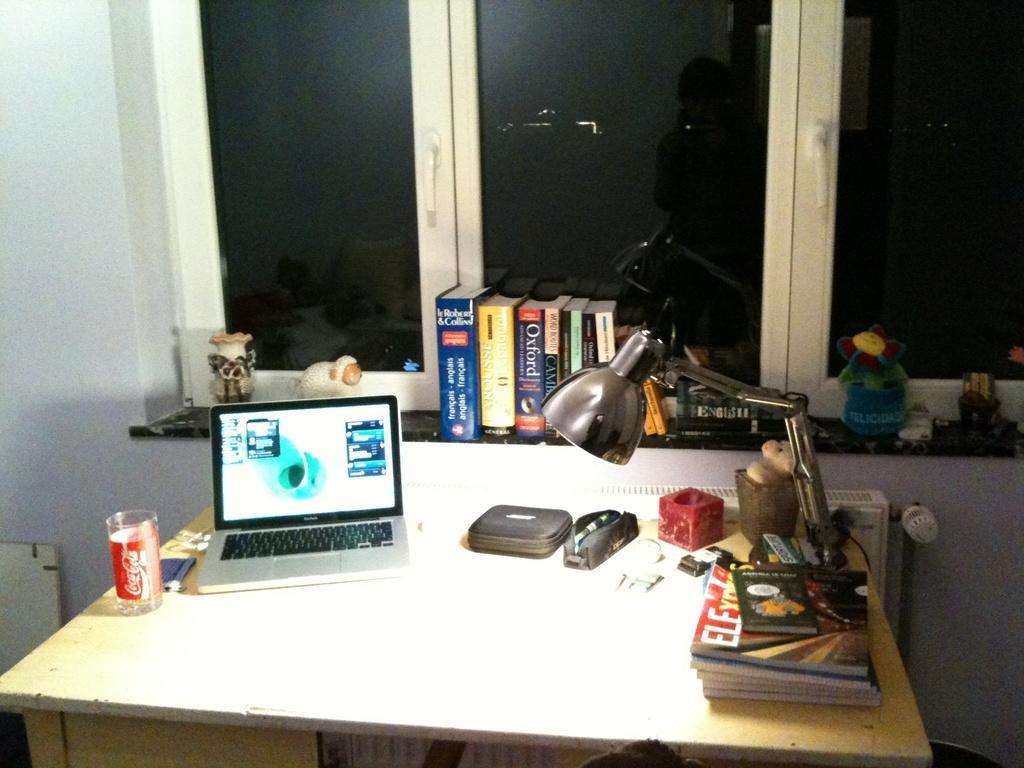Describe this image in one or two sentences. This is the wooden table with a laptop,tumbler,pouch,pen stand,books and a study lamp placed on the table. These are the books,a small flower vase,toy and some objects placed near the window. these are the windows with the doors. These are the door handles. 